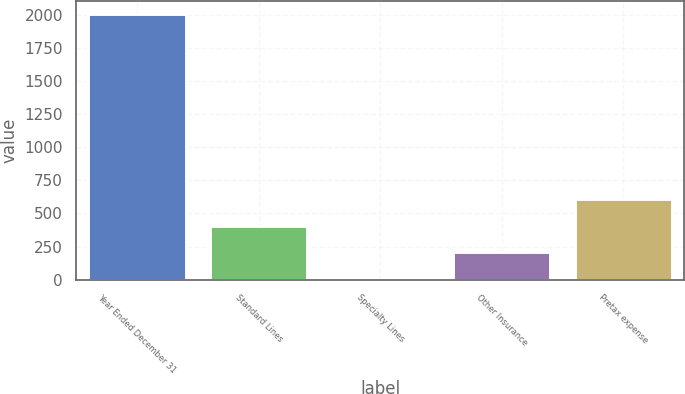Convert chart. <chart><loc_0><loc_0><loc_500><loc_500><bar_chart><fcel>Year Ended December 31<fcel>Standard Lines<fcel>Specialty Lines<fcel>Other Insurance<fcel>Pretax expense<nl><fcel>2006<fcel>406.8<fcel>7<fcel>206.9<fcel>606.7<nl></chart> 